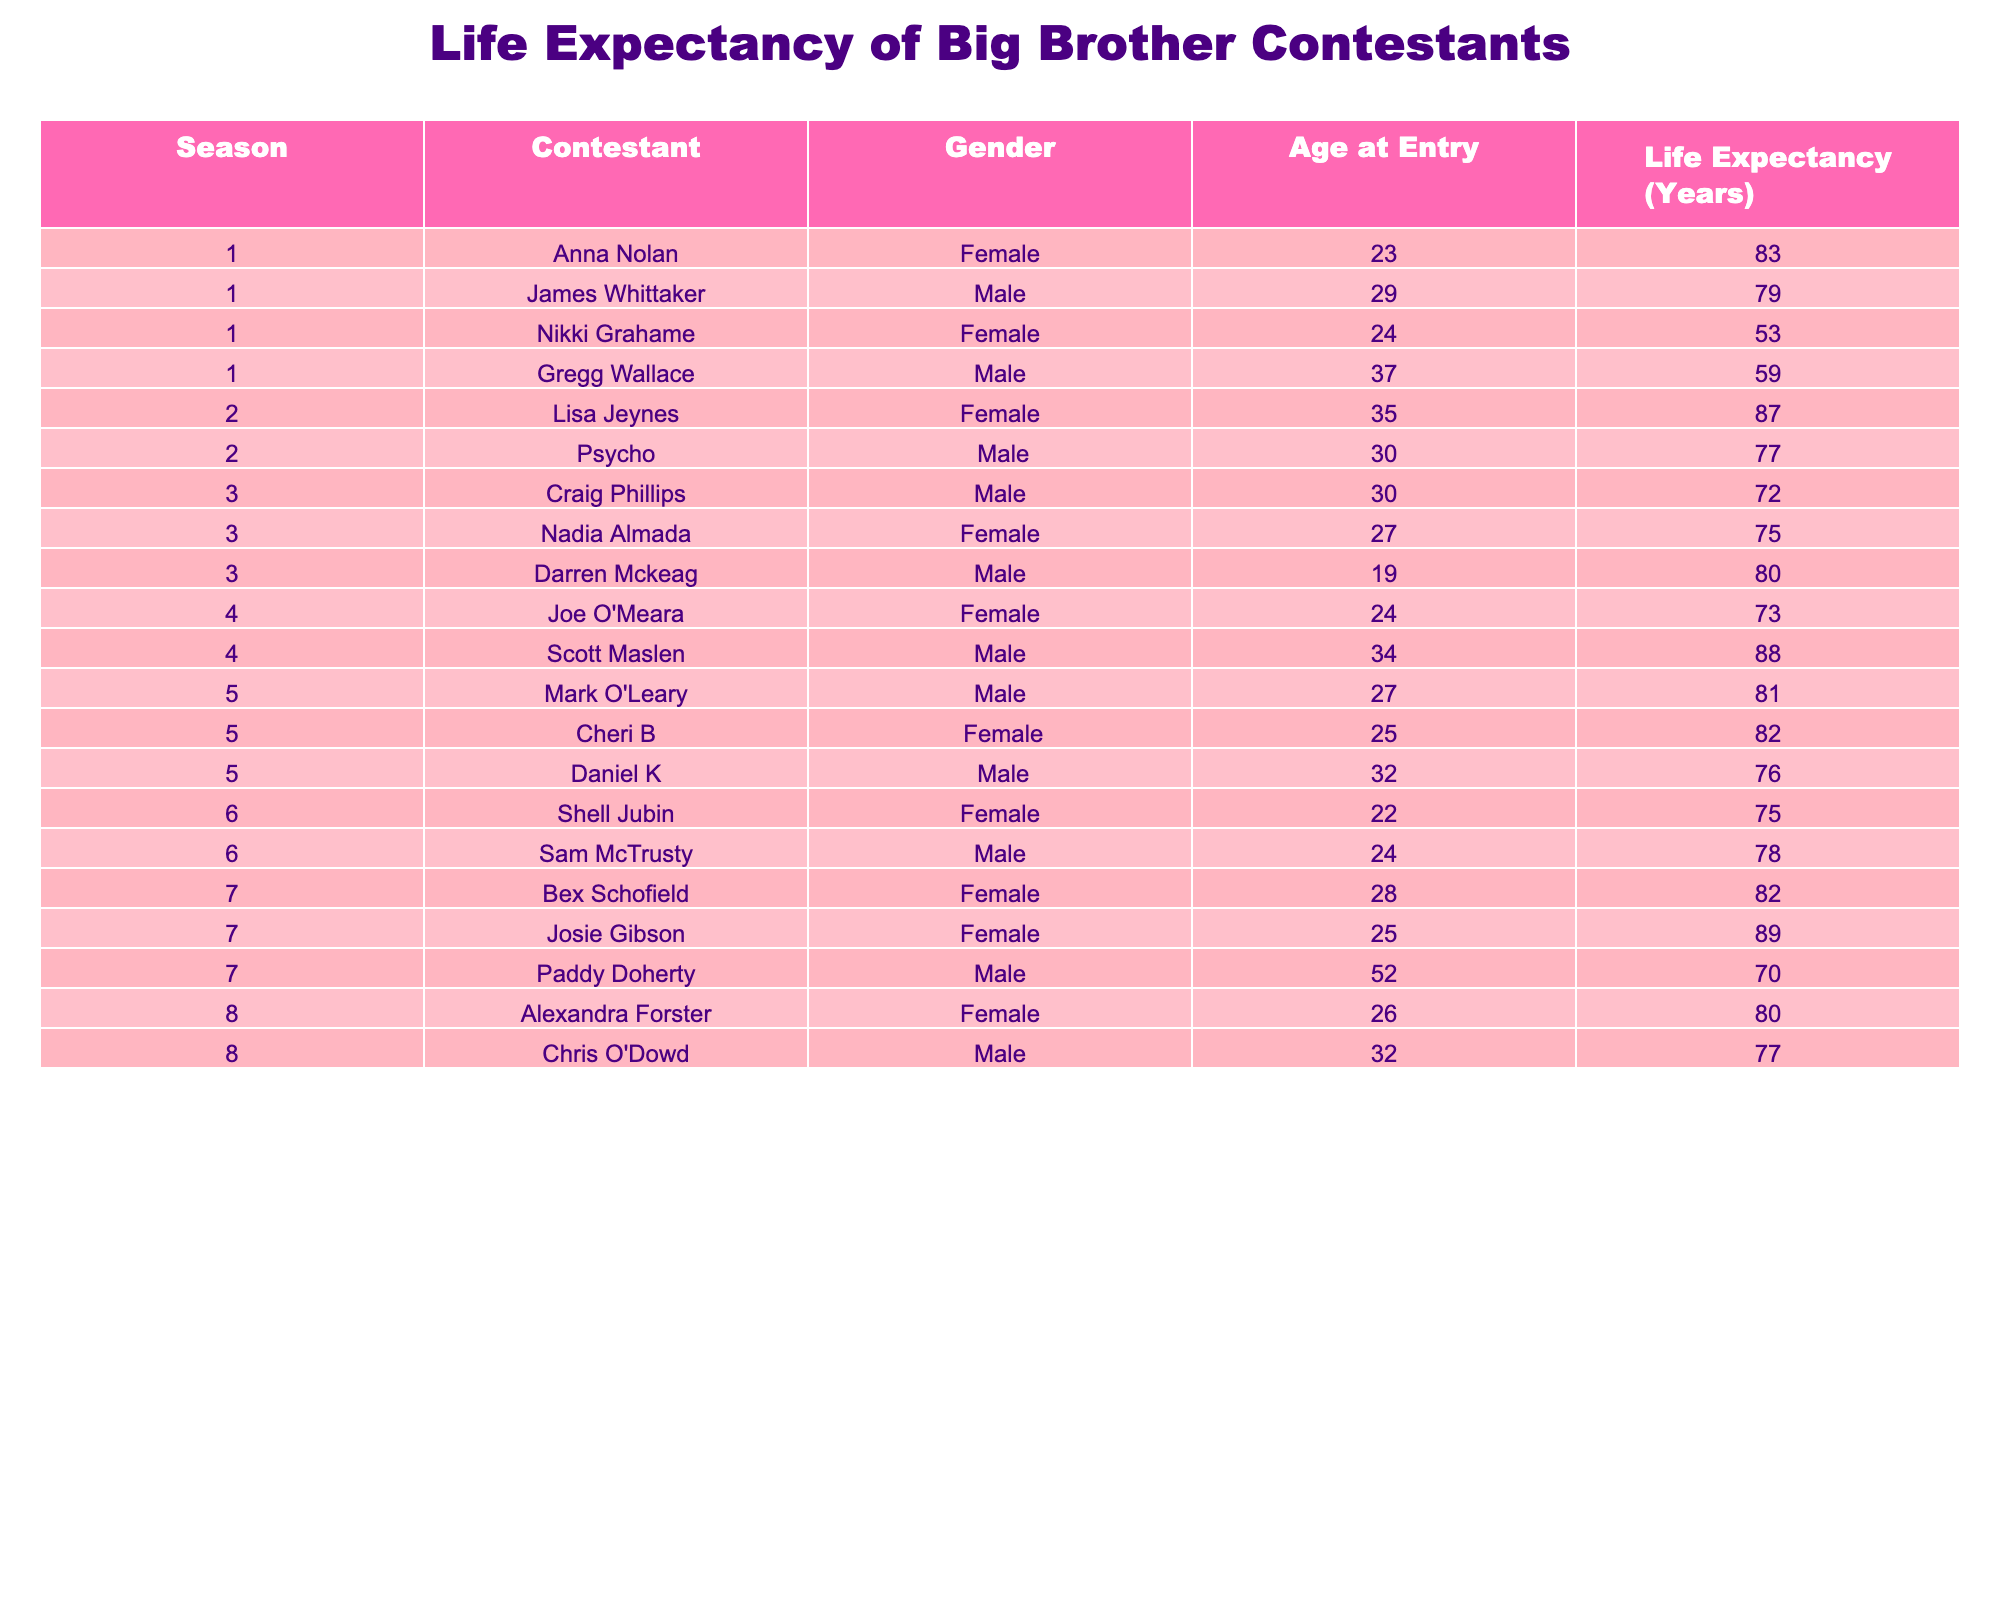What is the life expectancy of Lisa Jeynes? From the table, we can see that Lisa Jeynes is listed in Season 2 of the show, and her life expectancy is noted as 87 years.
Answer: 87 Which contestant has the highest life expectancy among male contestants? Looking at the table, Scott Maslen, who appeared in Season 4, has a life expectancy of 88 years, which is higher than any other male contestant's life expectancy listed.
Answer: 88 How many female contestants have a life expectancy of over 80 years? By examining the female contestants, we find that Anna Nolan (83), Lisa Jeynes (87), Josie Gibson (89), and Cheri B (82) all have life expectancies over 80 years. Therefore, there are four such contestants.
Answer: 4 What is the average life expectancy of female contestants? We calculate the average by taking the life expectancies of the female contestants (83, 53, 87, 73, 82, 75, 89, 80) and summing them up: 83 + 53 + 87 + 73 + 82 + 75 + 89 + 80 = 542. There are 8 female contestants, so the average is 542 / 8 = 67.75 years.
Answer: 67.75 Is there any contestant who has both a life expectancy under 60 years and is male? By checking the table, we notice that Gregg Wallace is the only male contestant with a life expectancy under 60 years, specifically at 59 years. Thus, the statement is true.
Answer: Yes Which season had the youngest male contestant and what was his age at entry? Looking through the table, the youngest male contestant was Darren Mckeag from Season 3, who entered at age 19.
Answer: 19 What is the total life expectancy of all contestants in Season 5? In Season 5, the contestants are Mark O'Leary (81), Cheri B (82), and Daniel K (76). The total life expectancy is calculated by summing these amounts: 81 + 82 + 76 = 239.
Answer: 239 How many male contestants have a life expectancy of at least 75 years? Referring to the male contestants listed, we have James Whittaker (79), Psycho (77), Craig Phillips (72), Darren Mckeag (80), Scott Maslen (88), Mark O'Leary (81), and Daniel K (76). Among these, six contestants have a life expectancy of at least 75 years.
Answer: 6 